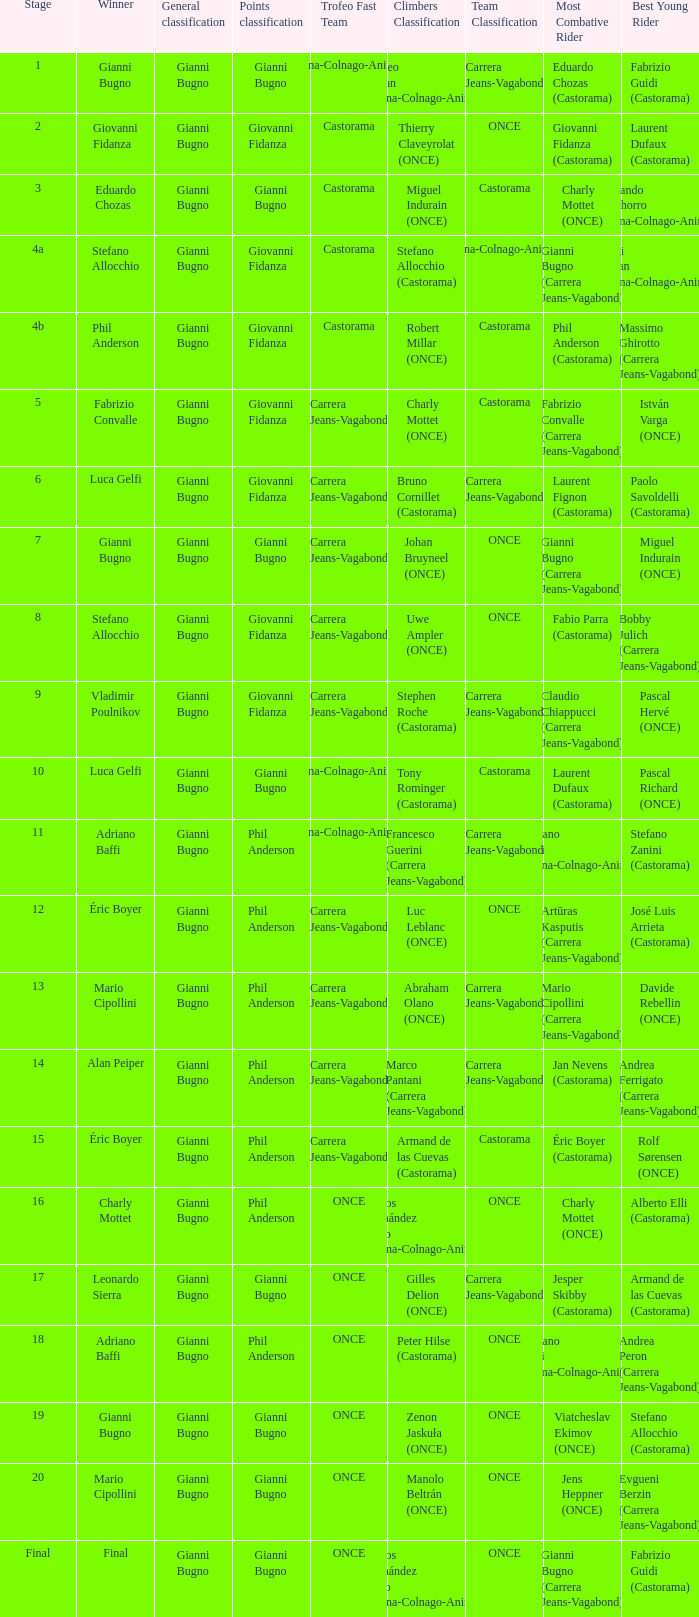What is the stage when the winner is charly mottet? 16.0. 